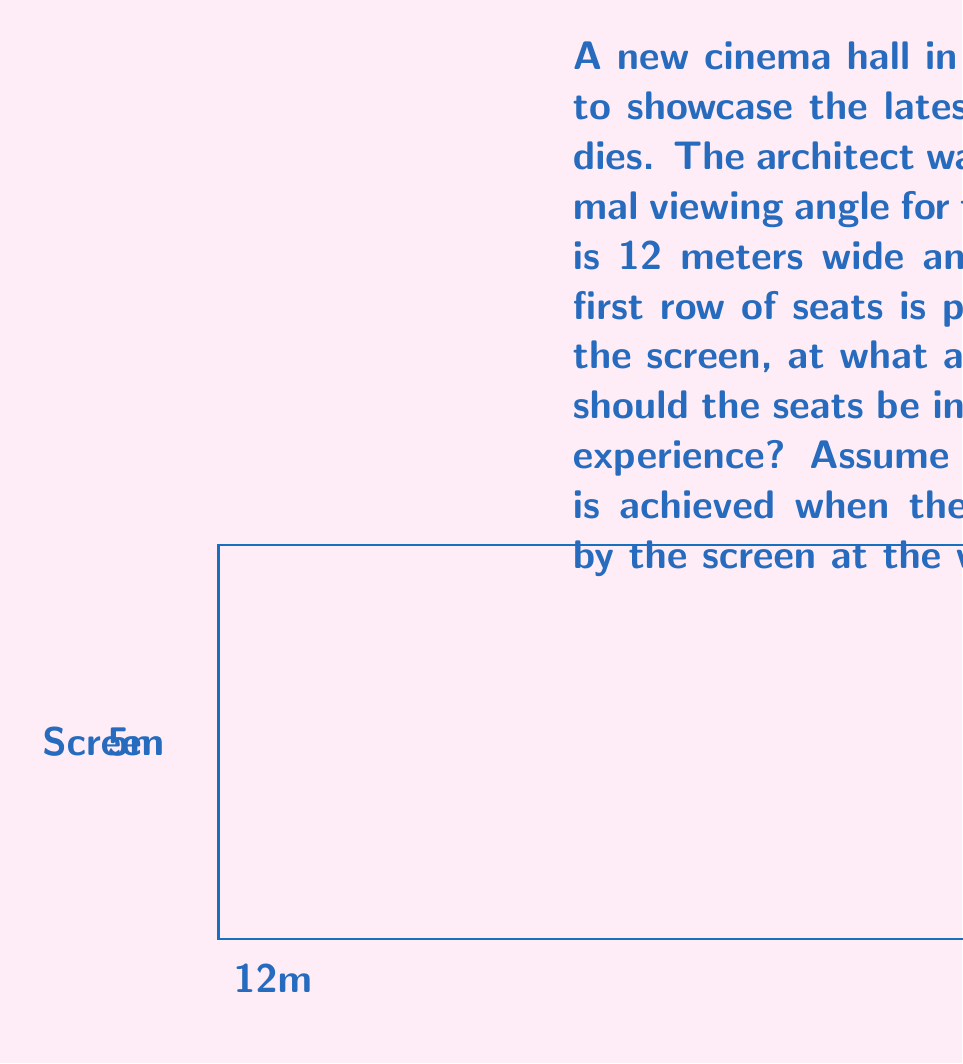Teach me how to tackle this problem. Let's approach this step-by-step:

1) The vertical angle subtended by the screen at the viewer's eye is maximized when the viewer's line of sight is perpendicular to the diagonal of the screen.

2) We need to find the angle this diagonal makes with the horizontal. Let's call this angle α.

3) The diagonal of the screen can be calculated using the Pythagorean theorem:
   $$d = \sqrt{12^2 + 5^2} = \sqrt{144 + 25} = \sqrt{169} = 13\text{ meters}$$

4) The angle α can be found using the arctangent function:
   $$\alpha = \arctan(\frac{5}{12})$$

5) Now, we need to find the angle θ that makes the viewer's line of sight perpendicular to this diagonal.

6) If we draw a line from the viewer's eye perpendicular to the diagonal, it forms two right triangles. In the right triangle formed with the horizontal, θ is the complement of α.

7) Therefore:
   $$\theta = 90° - \alpha = 90° - \arctan(\frac{5}{12})$$

8) Calculating this:
   $$\theta = 90° - \arctan(\frac{5}{12}) \approx 90° - 22.62° = 67.38°$$

9) This angle θ is the optimal inclination for the seats.
Answer: $67.38°$ 